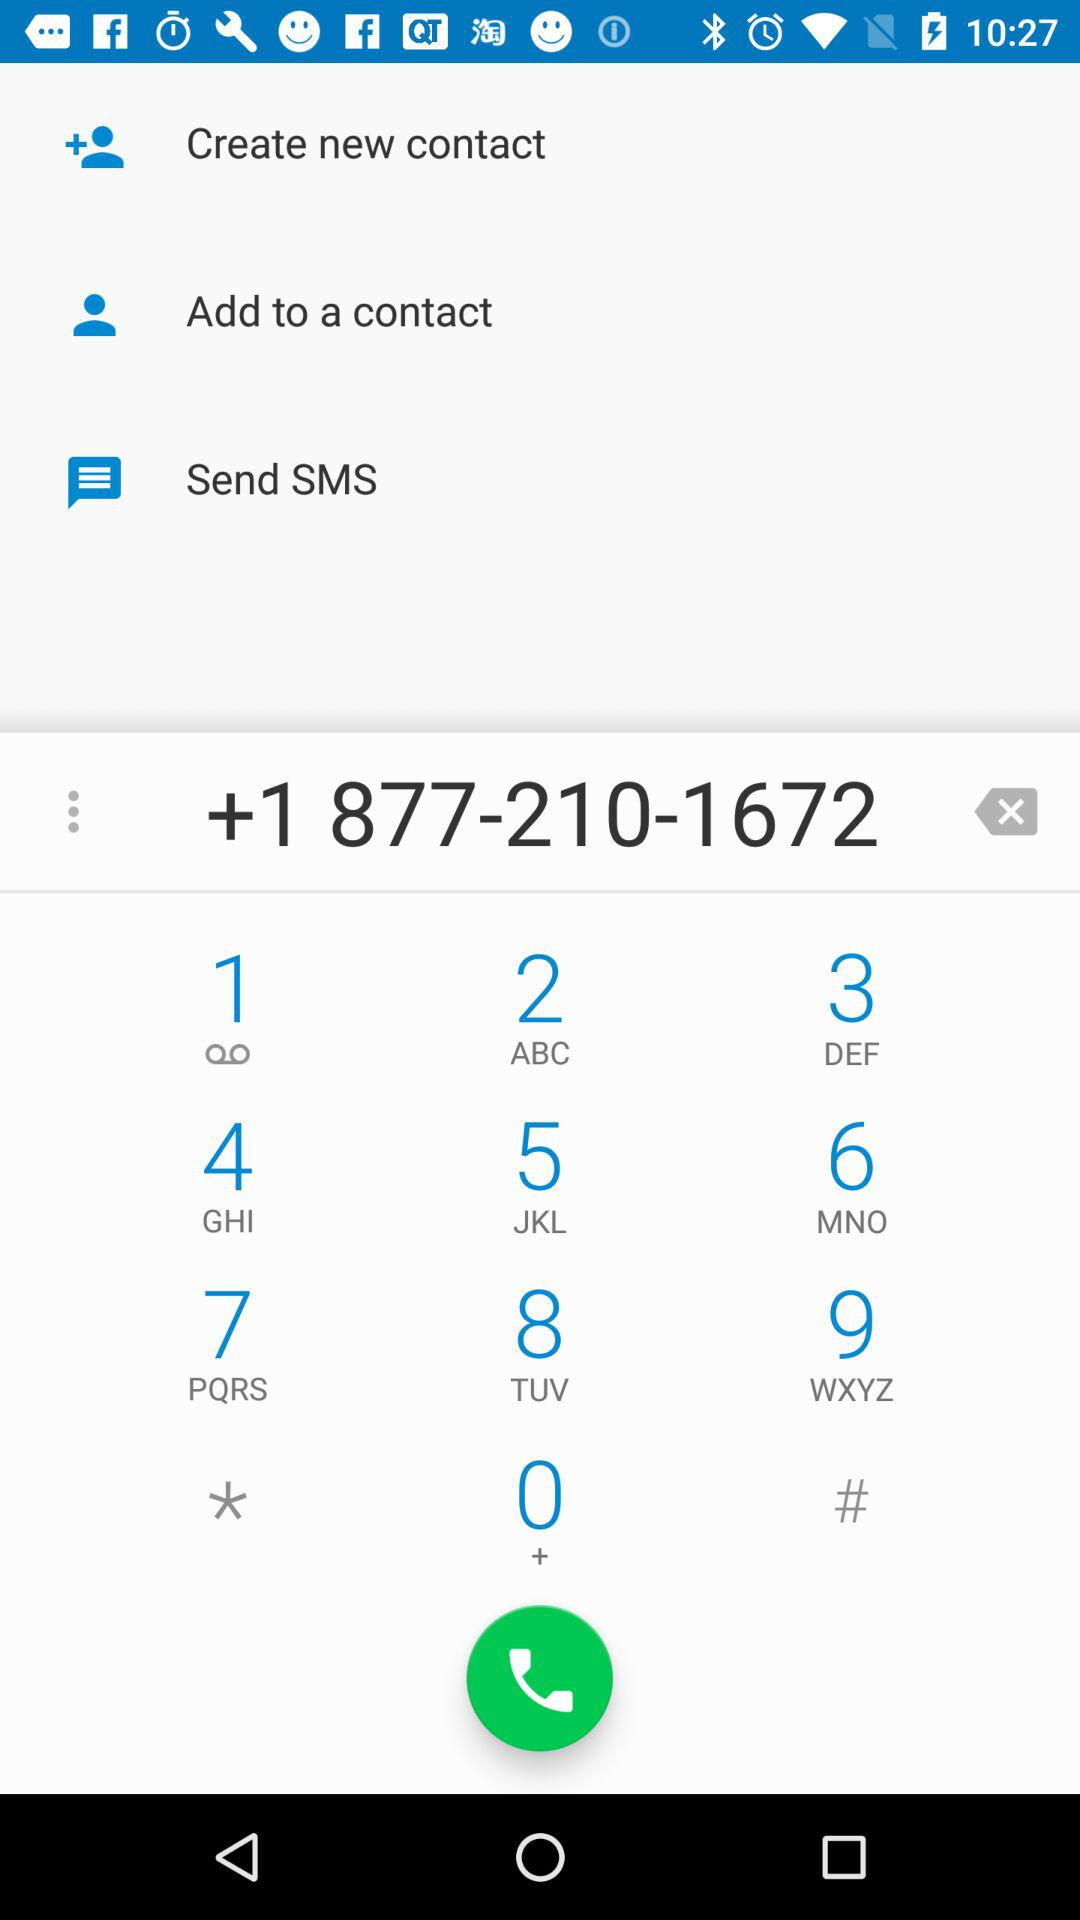What is the phone number? The phone number is +1 877-210-1672. 